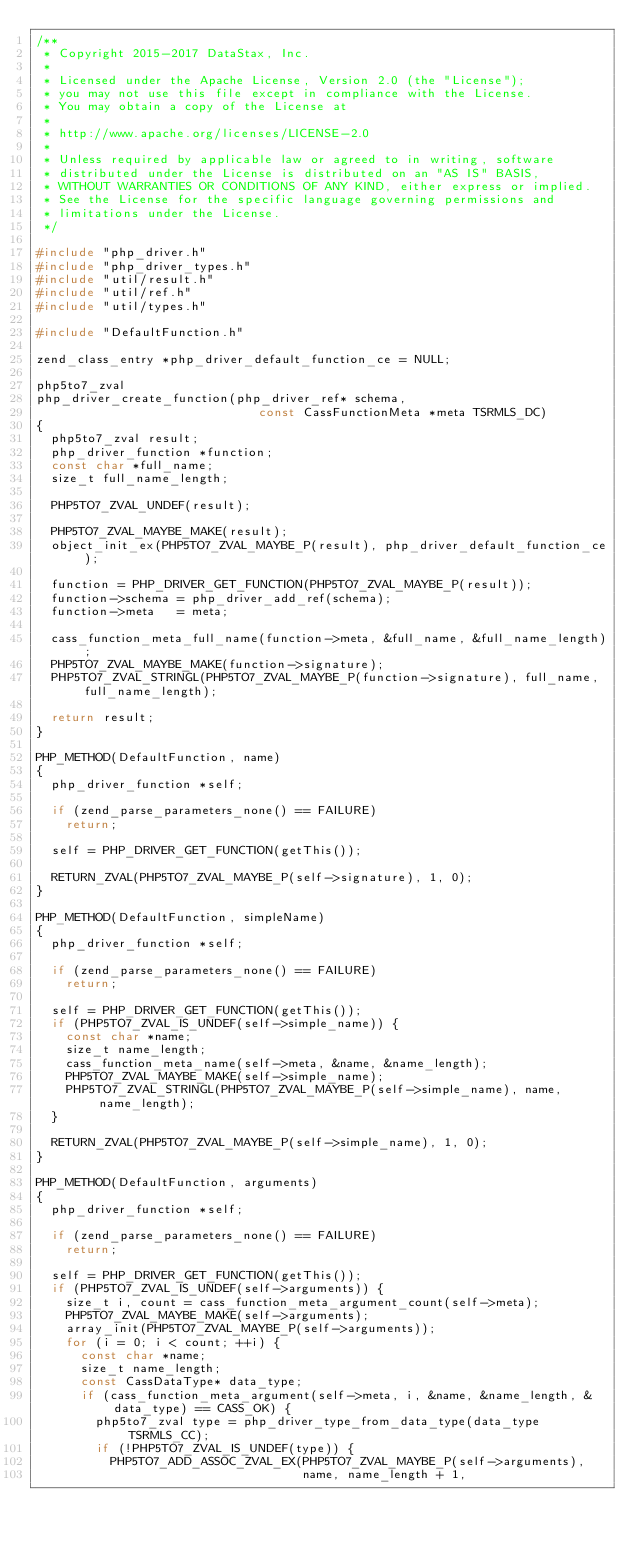<code> <loc_0><loc_0><loc_500><loc_500><_C_>/**
 * Copyright 2015-2017 DataStax, Inc.
 *
 * Licensed under the Apache License, Version 2.0 (the "License");
 * you may not use this file except in compliance with the License.
 * You may obtain a copy of the License at
 *
 * http://www.apache.org/licenses/LICENSE-2.0
 *
 * Unless required by applicable law or agreed to in writing, software
 * distributed under the License is distributed on an "AS IS" BASIS,
 * WITHOUT WARRANTIES OR CONDITIONS OF ANY KIND, either express or implied.
 * See the License for the specific language governing permissions and
 * limitations under the License.
 */

#include "php_driver.h"
#include "php_driver_types.h"
#include "util/result.h"
#include "util/ref.h"
#include "util/types.h"

#include "DefaultFunction.h"

zend_class_entry *php_driver_default_function_ce = NULL;

php5to7_zval
php_driver_create_function(php_driver_ref* schema,
                              const CassFunctionMeta *meta TSRMLS_DC)
{
  php5to7_zval result;
  php_driver_function *function;
  const char *full_name;
  size_t full_name_length;

  PHP5TO7_ZVAL_UNDEF(result);

  PHP5TO7_ZVAL_MAYBE_MAKE(result);
  object_init_ex(PHP5TO7_ZVAL_MAYBE_P(result), php_driver_default_function_ce);

  function = PHP_DRIVER_GET_FUNCTION(PHP5TO7_ZVAL_MAYBE_P(result));
  function->schema = php_driver_add_ref(schema);
  function->meta   = meta;

  cass_function_meta_full_name(function->meta, &full_name, &full_name_length);
  PHP5TO7_ZVAL_MAYBE_MAKE(function->signature);
  PHP5TO7_ZVAL_STRINGL(PHP5TO7_ZVAL_MAYBE_P(function->signature), full_name, full_name_length);

  return result;
}

PHP_METHOD(DefaultFunction, name)
{
  php_driver_function *self;

  if (zend_parse_parameters_none() == FAILURE)
    return;

  self = PHP_DRIVER_GET_FUNCTION(getThis());

  RETURN_ZVAL(PHP5TO7_ZVAL_MAYBE_P(self->signature), 1, 0);
}

PHP_METHOD(DefaultFunction, simpleName)
{
  php_driver_function *self;

  if (zend_parse_parameters_none() == FAILURE)
    return;

  self = PHP_DRIVER_GET_FUNCTION(getThis());
  if (PHP5TO7_ZVAL_IS_UNDEF(self->simple_name)) {
    const char *name;
    size_t name_length;
    cass_function_meta_name(self->meta, &name, &name_length);
    PHP5TO7_ZVAL_MAYBE_MAKE(self->simple_name);
    PHP5TO7_ZVAL_STRINGL(PHP5TO7_ZVAL_MAYBE_P(self->simple_name), name, name_length);
  }

  RETURN_ZVAL(PHP5TO7_ZVAL_MAYBE_P(self->simple_name), 1, 0);
}

PHP_METHOD(DefaultFunction, arguments)
{
  php_driver_function *self;

  if (zend_parse_parameters_none() == FAILURE)
    return;

  self = PHP_DRIVER_GET_FUNCTION(getThis());
  if (PHP5TO7_ZVAL_IS_UNDEF(self->arguments)) {
    size_t i, count = cass_function_meta_argument_count(self->meta);
    PHP5TO7_ZVAL_MAYBE_MAKE(self->arguments);
    array_init(PHP5TO7_ZVAL_MAYBE_P(self->arguments));
    for (i = 0; i < count; ++i) {
      const char *name;
      size_t name_length;
      const CassDataType* data_type;
      if (cass_function_meta_argument(self->meta, i, &name, &name_length, &data_type) == CASS_OK) {
        php5to7_zval type = php_driver_type_from_data_type(data_type TSRMLS_CC);
        if (!PHP5TO7_ZVAL_IS_UNDEF(type)) {
          PHP5TO7_ADD_ASSOC_ZVAL_EX(PHP5TO7_ZVAL_MAYBE_P(self->arguments),
                                    name, name_length + 1,</code> 